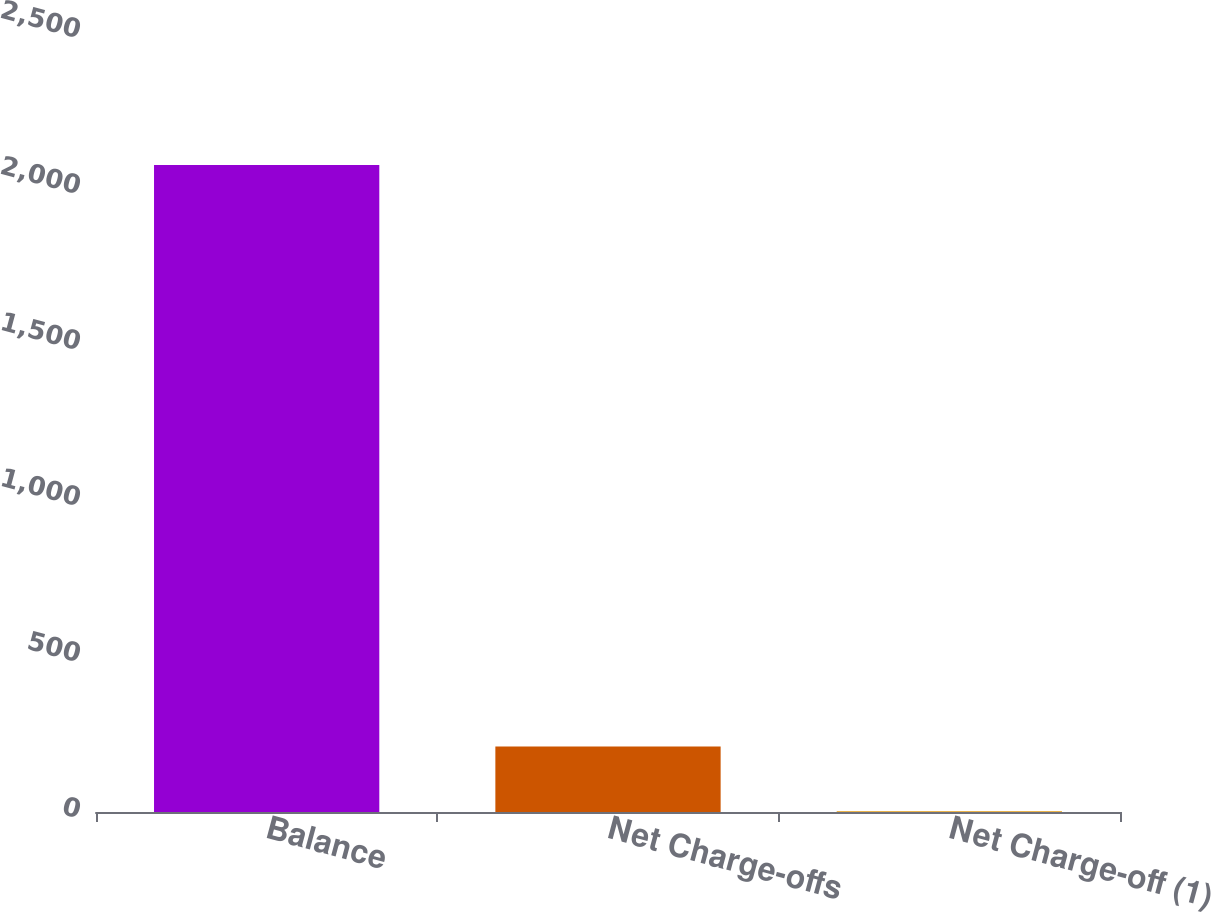<chart> <loc_0><loc_0><loc_500><loc_500><bar_chart><fcel>Balance<fcel>Net Charge-offs<fcel>Net Charge-off (1)<nl><fcel>2074<fcel>209.79<fcel>2.66<nl></chart> 